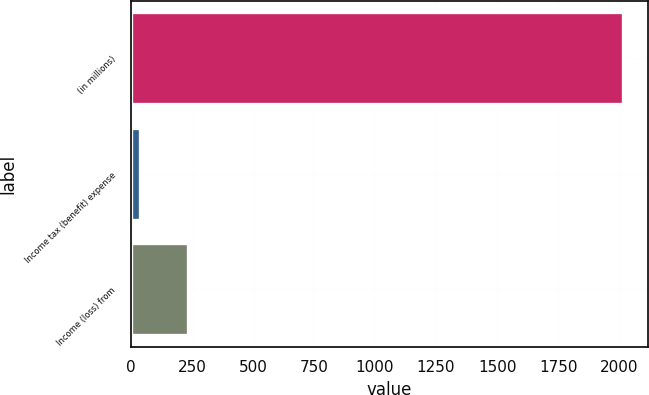Convert chart. <chart><loc_0><loc_0><loc_500><loc_500><bar_chart><fcel>(in millions)<fcel>Income tax (benefit) expense<fcel>Income (loss) from<nl><fcel>2016<fcel>36<fcel>234<nl></chart> 